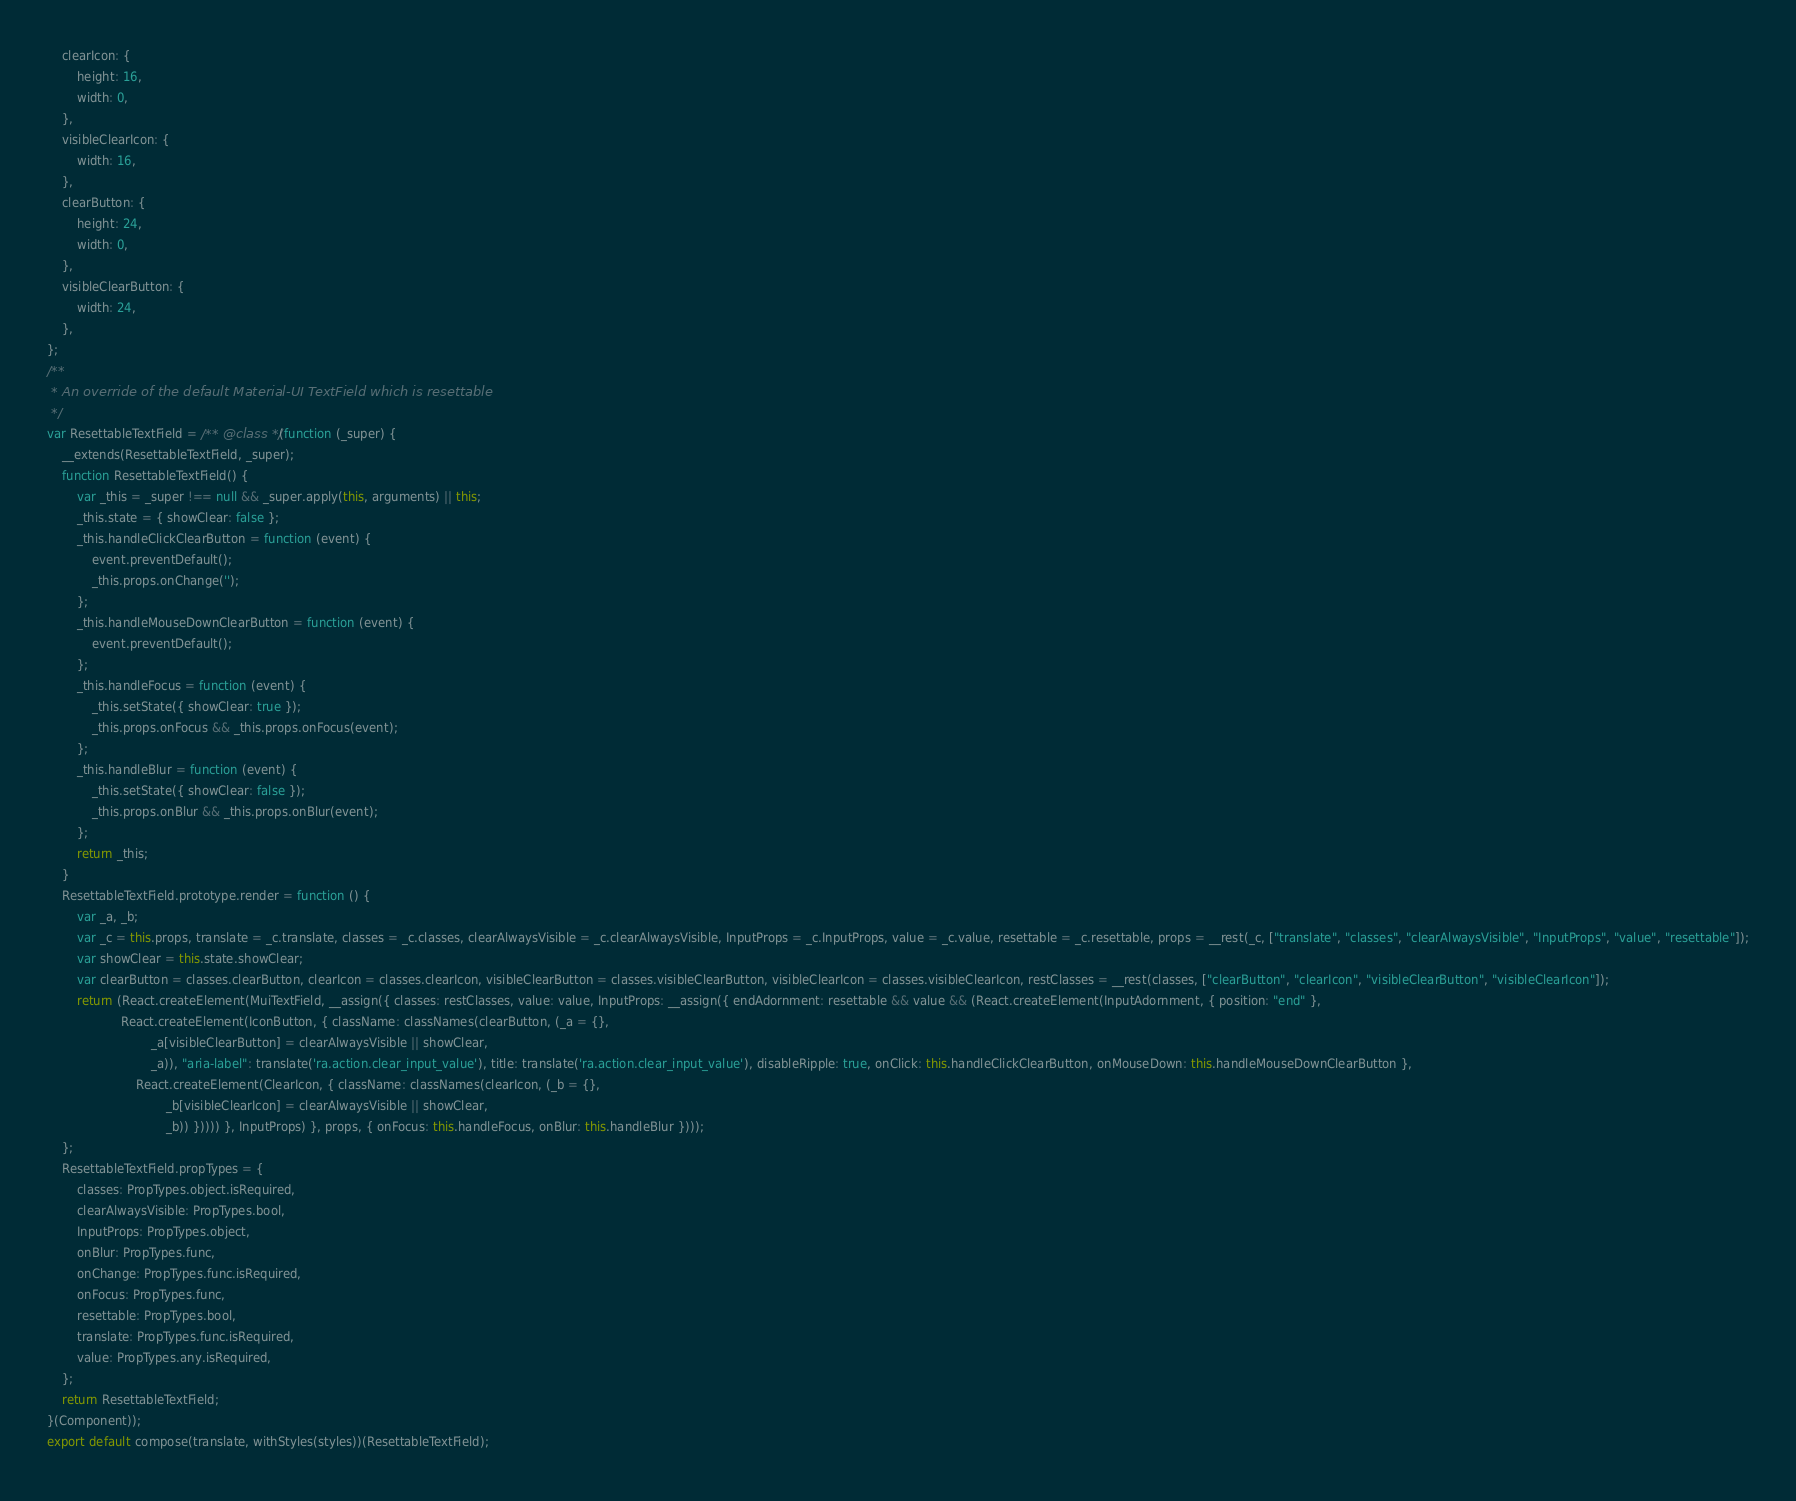Convert code to text. <code><loc_0><loc_0><loc_500><loc_500><_JavaScript_>    clearIcon: {
        height: 16,
        width: 0,
    },
    visibleClearIcon: {
        width: 16,
    },
    clearButton: {
        height: 24,
        width: 0,
    },
    visibleClearButton: {
        width: 24,
    },
};
/**
 * An override of the default Material-UI TextField which is resettable
 */
var ResettableTextField = /** @class */ (function (_super) {
    __extends(ResettableTextField, _super);
    function ResettableTextField() {
        var _this = _super !== null && _super.apply(this, arguments) || this;
        _this.state = { showClear: false };
        _this.handleClickClearButton = function (event) {
            event.preventDefault();
            _this.props.onChange('');
        };
        _this.handleMouseDownClearButton = function (event) {
            event.preventDefault();
        };
        _this.handleFocus = function (event) {
            _this.setState({ showClear: true });
            _this.props.onFocus && _this.props.onFocus(event);
        };
        _this.handleBlur = function (event) {
            _this.setState({ showClear: false });
            _this.props.onBlur && _this.props.onBlur(event);
        };
        return _this;
    }
    ResettableTextField.prototype.render = function () {
        var _a, _b;
        var _c = this.props, translate = _c.translate, classes = _c.classes, clearAlwaysVisible = _c.clearAlwaysVisible, InputProps = _c.InputProps, value = _c.value, resettable = _c.resettable, props = __rest(_c, ["translate", "classes", "clearAlwaysVisible", "InputProps", "value", "resettable"]);
        var showClear = this.state.showClear;
        var clearButton = classes.clearButton, clearIcon = classes.clearIcon, visibleClearButton = classes.visibleClearButton, visibleClearIcon = classes.visibleClearIcon, restClasses = __rest(classes, ["clearButton", "clearIcon", "visibleClearButton", "visibleClearIcon"]);
        return (React.createElement(MuiTextField, __assign({ classes: restClasses, value: value, InputProps: __assign({ endAdornment: resettable && value && (React.createElement(InputAdornment, { position: "end" },
                    React.createElement(IconButton, { className: classNames(clearButton, (_a = {},
                            _a[visibleClearButton] = clearAlwaysVisible || showClear,
                            _a)), "aria-label": translate('ra.action.clear_input_value'), title: translate('ra.action.clear_input_value'), disableRipple: true, onClick: this.handleClickClearButton, onMouseDown: this.handleMouseDownClearButton },
                        React.createElement(ClearIcon, { className: classNames(clearIcon, (_b = {},
                                _b[visibleClearIcon] = clearAlwaysVisible || showClear,
                                _b)) })))) }, InputProps) }, props, { onFocus: this.handleFocus, onBlur: this.handleBlur })));
    };
    ResettableTextField.propTypes = {
        classes: PropTypes.object.isRequired,
        clearAlwaysVisible: PropTypes.bool,
        InputProps: PropTypes.object,
        onBlur: PropTypes.func,
        onChange: PropTypes.func.isRequired,
        onFocus: PropTypes.func,
        resettable: PropTypes.bool,
        translate: PropTypes.func.isRequired,
        value: PropTypes.any.isRequired,
    };
    return ResettableTextField;
}(Component));
export default compose(translate, withStyles(styles))(ResettableTextField);
</code> 